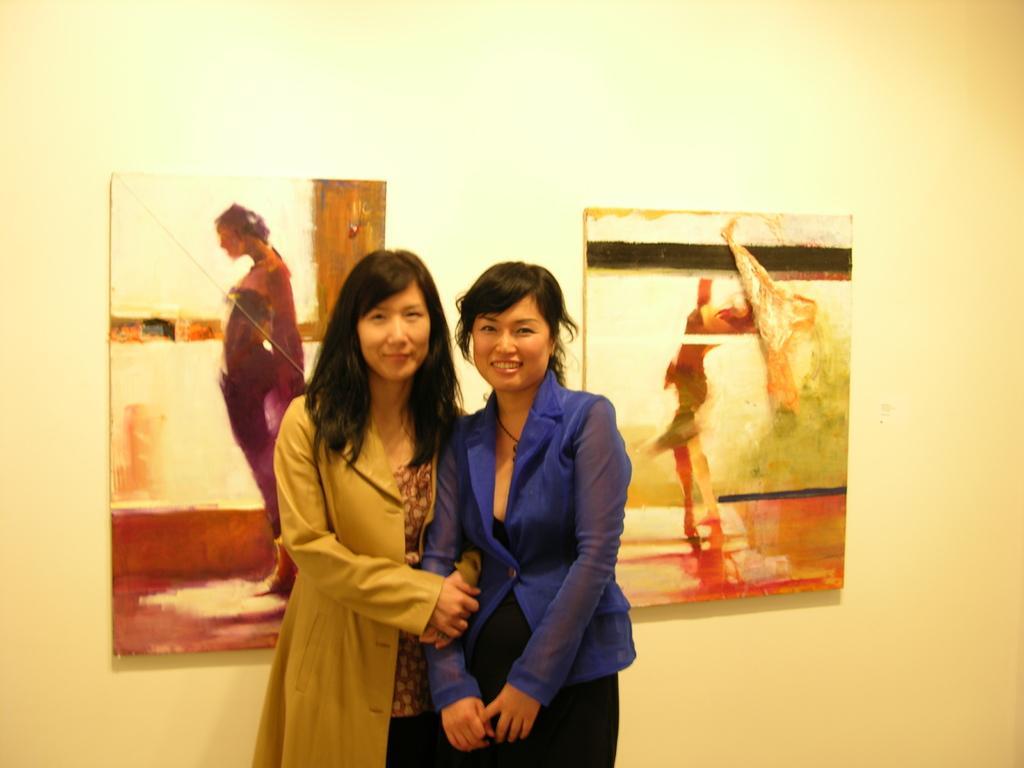Could you give a brief overview of what you see in this image? In this image I can see two women standing and wearing a brown coat and blue coat. Back Side I can see frames are attached to the wall. The wall is in white and cream. 